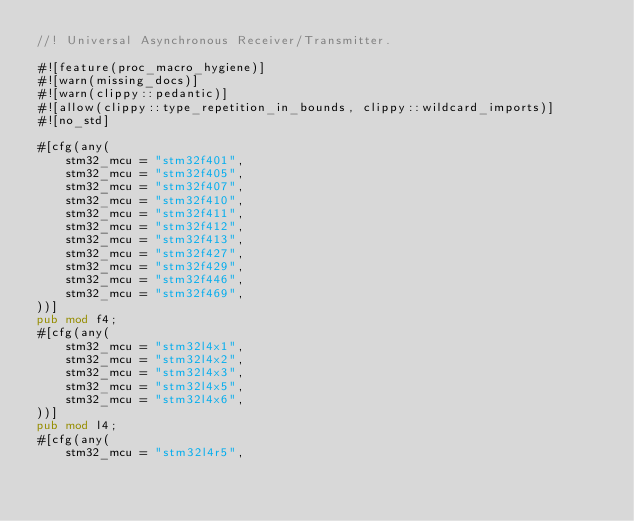<code> <loc_0><loc_0><loc_500><loc_500><_Rust_>//! Universal Asynchronous Receiver/Transmitter.

#![feature(proc_macro_hygiene)]
#![warn(missing_docs)]
#![warn(clippy::pedantic)]
#![allow(clippy::type_repetition_in_bounds, clippy::wildcard_imports)]
#![no_std]

#[cfg(any(
    stm32_mcu = "stm32f401",
    stm32_mcu = "stm32f405",
    stm32_mcu = "stm32f407",
    stm32_mcu = "stm32f410",
    stm32_mcu = "stm32f411",
    stm32_mcu = "stm32f412",
    stm32_mcu = "stm32f413",
    stm32_mcu = "stm32f427",
    stm32_mcu = "stm32f429",
    stm32_mcu = "stm32f446",
    stm32_mcu = "stm32f469",
))]
pub mod f4;
#[cfg(any(
    stm32_mcu = "stm32l4x1",
    stm32_mcu = "stm32l4x2",
    stm32_mcu = "stm32l4x3",
    stm32_mcu = "stm32l4x5",
    stm32_mcu = "stm32l4x6",
))]
pub mod l4;
#[cfg(any(
    stm32_mcu = "stm32l4r5",</code> 